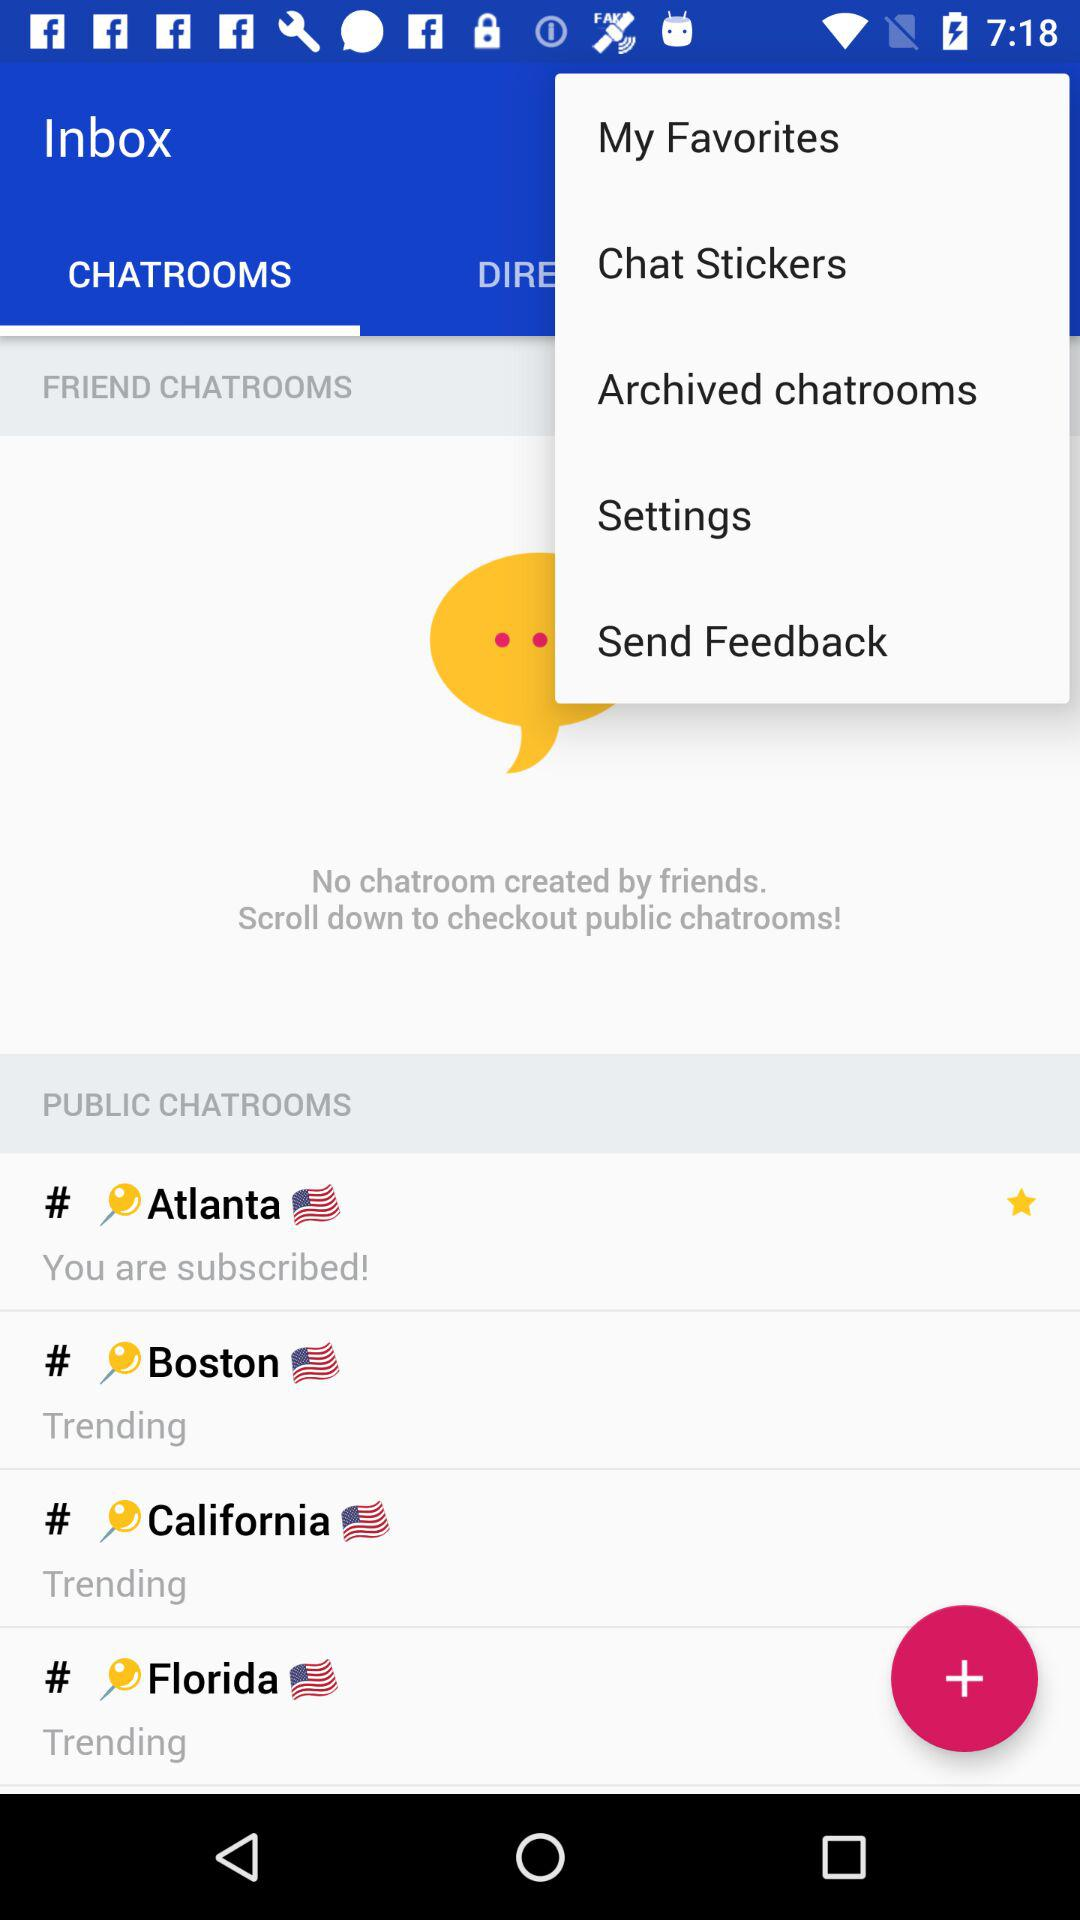Which of the chatrooms had been subscribed to? The chatroom is "Atlanta". 